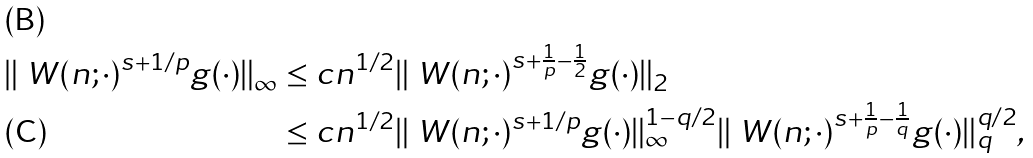Convert formula to latex. <formula><loc_0><loc_0><loc_500><loc_500>\| \ W ( n ; \cdot ) ^ { s + 1 / p } g ( \cdot ) \| _ { \infty } & \leq c n ^ { 1 / 2 } \| \ W ( n ; \cdot ) ^ { s + \frac { 1 } { p } - \frac { 1 } { 2 } } g ( \cdot ) \| _ { 2 } \\ & \leq c n ^ { 1 / 2 } \| \ W ( n ; \cdot ) ^ { s + 1 / p } g ( \cdot ) \| _ { \infty } ^ { 1 - q / 2 } \| \ W ( n ; \cdot ) ^ { s + \frac { 1 } { p } - \frac { 1 } { q } } g ( \cdot ) \| _ { q } ^ { q / 2 } ,</formula> 